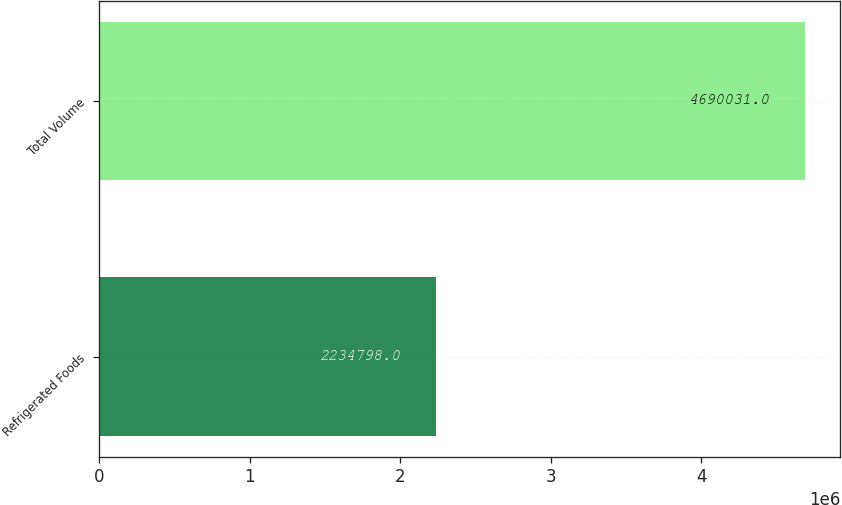Convert chart. <chart><loc_0><loc_0><loc_500><loc_500><bar_chart><fcel>Refrigerated Foods<fcel>Total Volume<nl><fcel>2.2348e+06<fcel>4.69003e+06<nl></chart> 